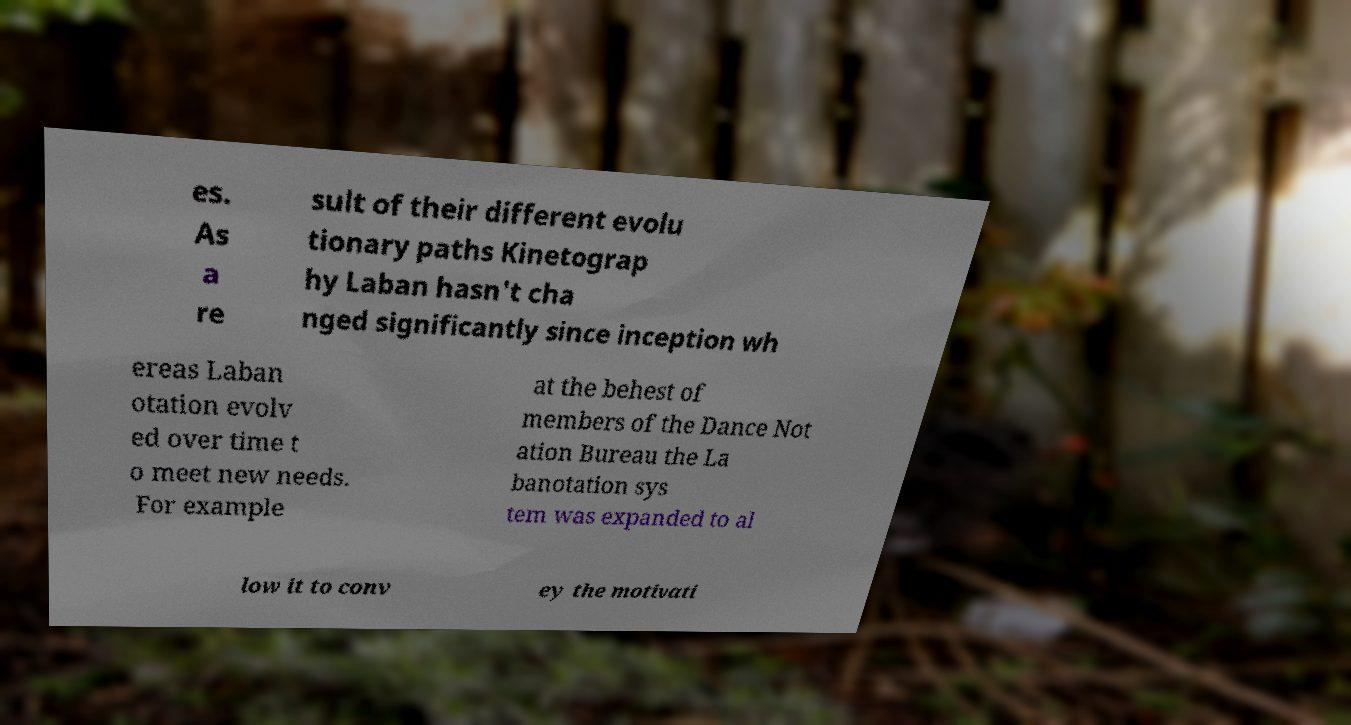Please read and relay the text visible in this image. What does it say? es. As a re sult of their different evolu tionary paths Kinetograp hy Laban hasn't cha nged significantly since inception wh ereas Laban otation evolv ed over time t o meet new needs. For example at the behest of members of the Dance Not ation Bureau the La banotation sys tem was expanded to al low it to conv ey the motivati 